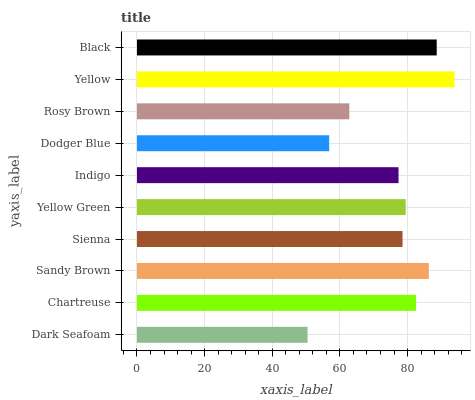Is Dark Seafoam the minimum?
Answer yes or no. Yes. Is Yellow the maximum?
Answer yes or no. Yes. Is Chartreuse the minimum?
Answer yes or no. No. Is Chartreuse the maximum?
Answer yes or no. No. Is Chartreuse greater than Dark Seafoam?
Answer yes or no. Yes. Is Dark Seafoam less than Chartreuse?
Answer yes or no. Yes. Is Dark Seafoam greater than Chartreuse?
Answer yes or no. No. Is Chartreuse less than Dark Seafoam?
Answer yes or no. No. Is Yellow Green the high median?
Answer yes or no. Yes. Is Sienna the low median?
Answer yes or no. Yes. Is Indigo the high median?
Answer yes or no. No. Is Yellow Green the low median?
Answer yes or no. No. 